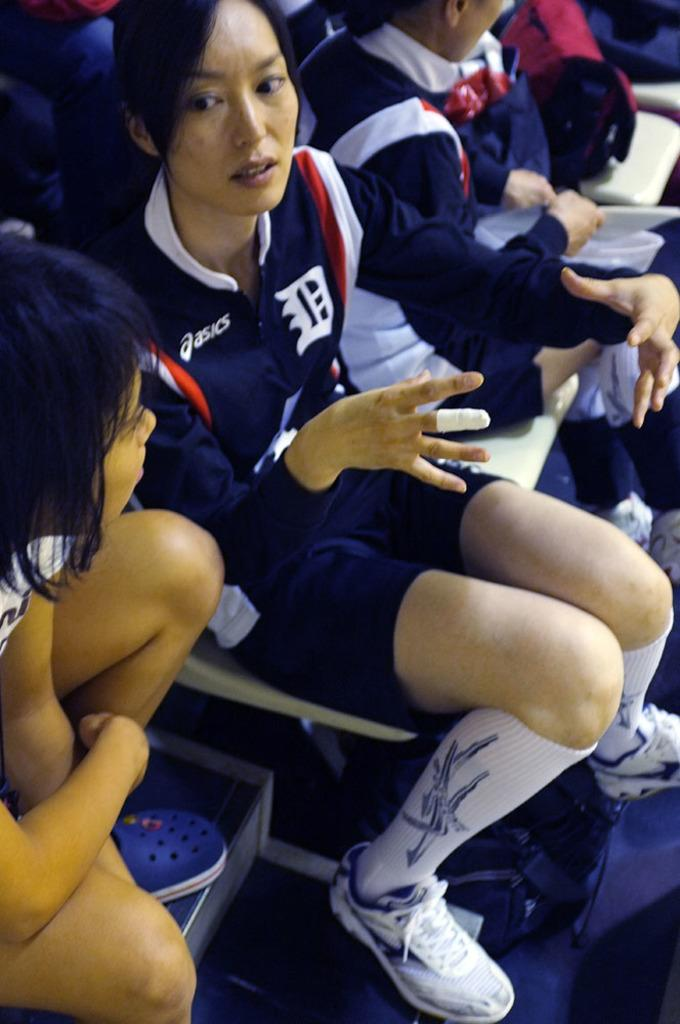<image>
Share a concise interpretation of the image provided. A woman is wearing an Asics jacket and talking to a girl. 